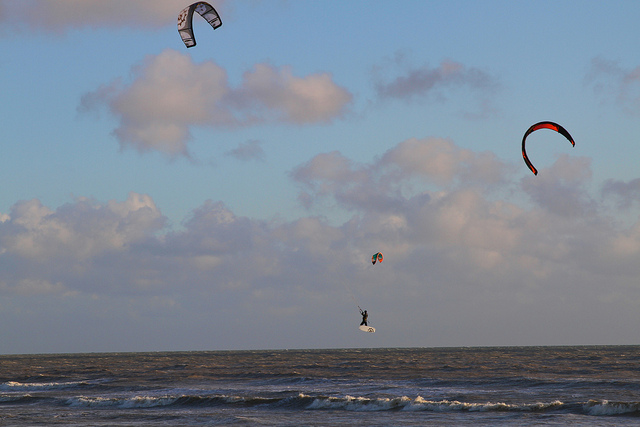Can you explain the sport of kite surfing to me, based on what you see? Kite surfing is a symphony of athleticism and artistry, where the surfer, connected to a harness, commands a large and vivid kite, using the wind as a partner to glide, jump, and surf across the water's surface. It's a dance with nature's own breath, imbued with moments of both serenity and thrill. 